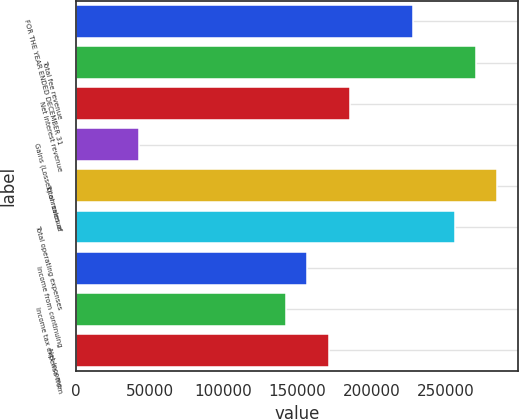Convert chart. <chart><loc_0><loc_0><loc_500><loc_500><bar_chart><fcel>FOR THE YEAR ENDED DECEMBER 31<fcel>Total fee revenue<fcel>Net interest revenue<fcel>Gains (Losses) on sales of<fcel>Total revenue<fcel>Total operating expenses<fcel>Income from continuing<fcel>Income tax expense from<fcel>Net income<nl><fcel>228068<fcel>270831<fcel>185306<fcel>42763.5<fcel>285085<fcel>256577<fcel>156797<fcel>142543<fcel>171051<nl></chart> 